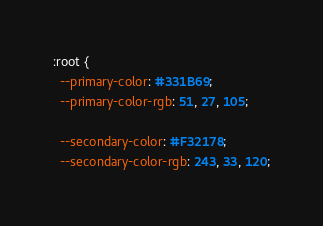Convert code to text. <code><loc_0><loc_0><loc_500><loc_500><_CSS_>:root {
  --primary-color: #331B69;
  --primary-color-rgb: 51, 27, 105;

  --secondary-color: #F32178;
  --secondary-color-rgb: 243, 33, 120;</code> 